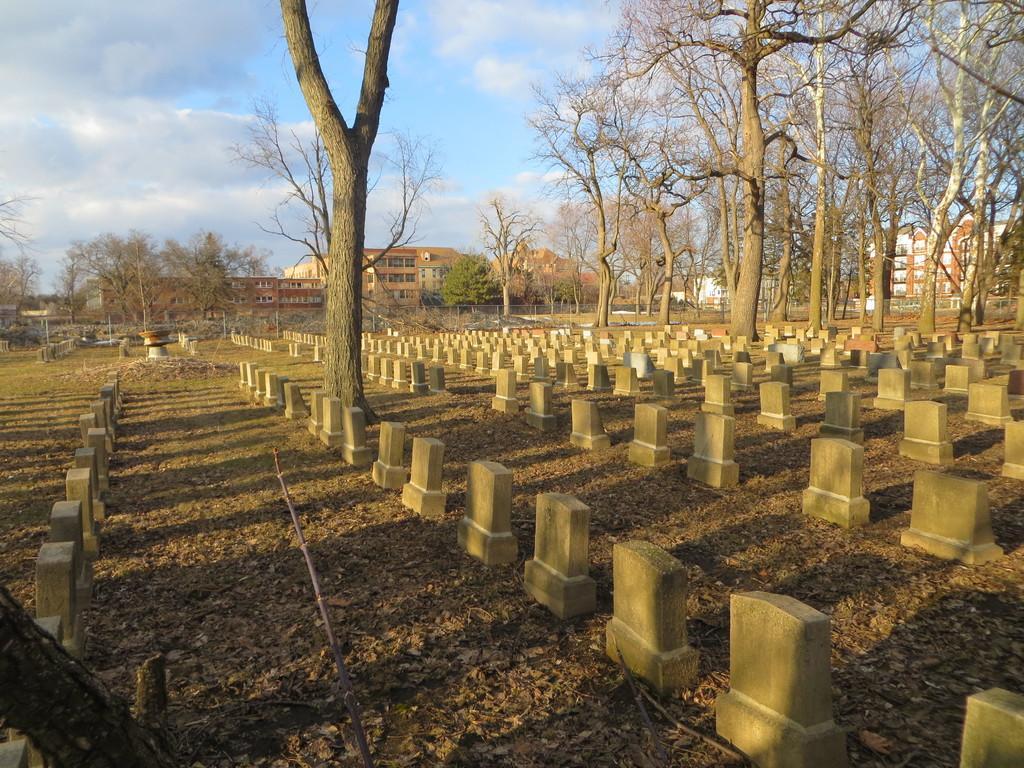Could you give a brief overview of what you see in this image? There are a lot of dry trees and in between them there are plenty of headstones and they are arranged in an order,behind the headstones there are few buildings and in the background there is a sky. 